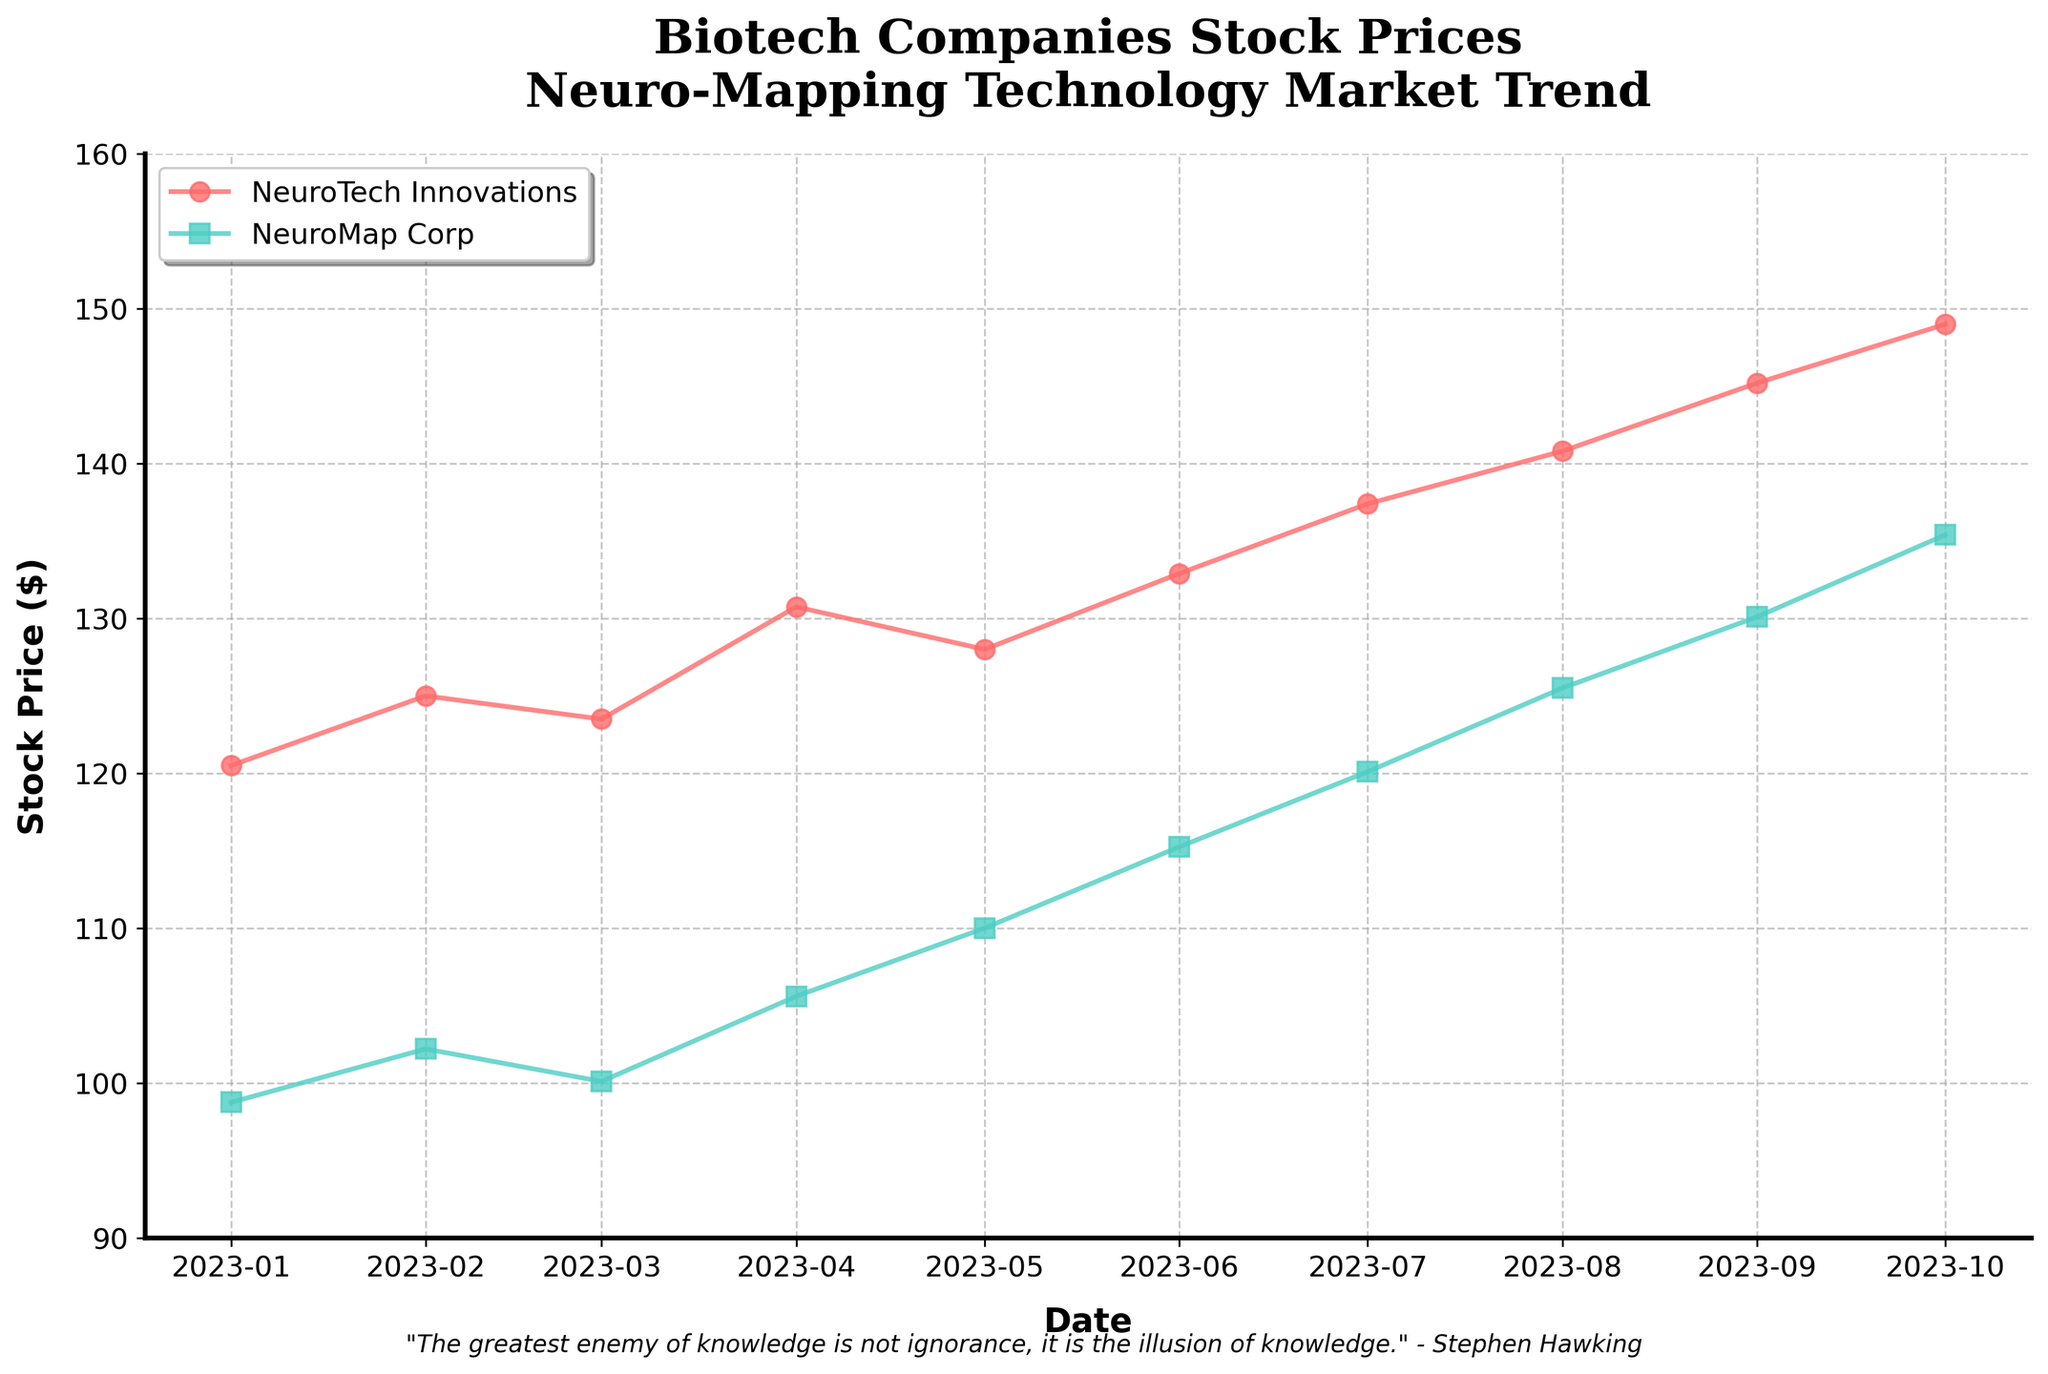What is the title of the plot? The title of the plot is visible at the top of the figure. It reads "Biotech Companies Stock Prices\nNeuro-Mapping Technology Market Trend".
Answer: Biotech Companies Stock Prices\nNeuro-Mapping Technology Market Trend Which company had the higher stock price in January 2023? By looking at the data points for January 2023, we see two points: NeuroTech Innovations at 120.50 and NeuroMap Corp at 98.75. NeuroTech Innovations has the higher stock price.
Answer: NeuroTech Innovations How do the stock prices of NeuroTech Innovations trend over the time shown in the plot? Observing the plot line for NeuroTech Innovations, it starts from January 2023 and consistently increases month by month until October 2023.
Answer: Consistently increasing What is the difference in stock price between NeuroTech Innovations and NeuroMap Corp on October 1, 2023? The stock price of NeuroTech Innovations on October 1, 2023 is 149.00, and the stock price of NeuroMap Corp on the same date is 135.40. The difference is calculated as 149.00 - 135.40.
Answer: 13.60 Which company shows a faster growth in stock prices over the plotted period? By analyzing the overall slopes of the lines, NeuroMap Corp starts from a lower base and shows a sharp increase, catching up with NeuroTech Innovations by crossing larger intervals each month.
Answer: NeuroMap Corp How many companies are shown in the plot? The plot has two distinct lines representing two companies, identifiable by different colors and markers.
Answer: Two During which months does NeuroMap Corp show the most significant increase in stock prices? From May to August 2023, the stock prices of NeuroMap Corp increased significantly, shown by a steeper rise in the plotted line.
Answer: May to August 2023 What is the general stock price range depicted in the y-axis of the plot? Looking at the y-axis labels, the stock prices range from 90 to 160.
Answer: 90 to 160 By how much did NeuroTech Innovations' stock price increase from January 1, 2023 to October 1, 2023? The stock price of NeuroTech Innovations on January 1, 2023, is 120.50, and on October 1, 2023, it is 149.00. The difference is calculated as 149.00 - 120.50.
Answer: 28.50 Which company had a higher stock price as of July 1, 2023, and what were the prices? Looking at the stock prices on July 1, 2023, NeuroTech Innovations had a price of 137.40, and NeuroMap Corp had a price of 120.10. NeuroTech Innovations had the higher stock price.
Answer: NeuroTech Innovations, 137.40 and 120.10 